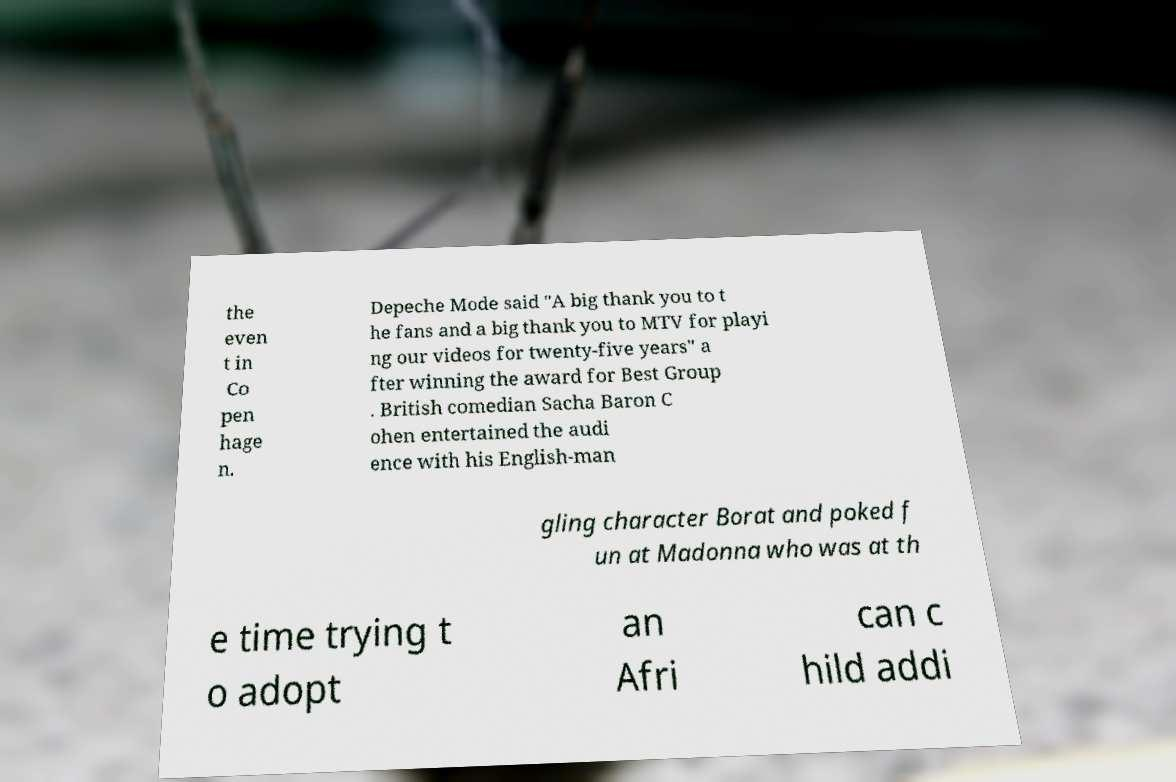Can you read and provide the text displayed in the image?This photo seems to have some interesting text. Can you extract and type it out for me? the even t in Co pen hage n. Depeche Mode said "A big thank you to t he fans and a big thank you to MTV for playi ng our videos for twenty-five years" a fter winning the award for Best Group . British comedian Sacha Baron C ohen entertained the audi ence with his English-man gling character Borat and poked f un at Madonna who was at th e time trying t o adopt an Afri can c hild addi 